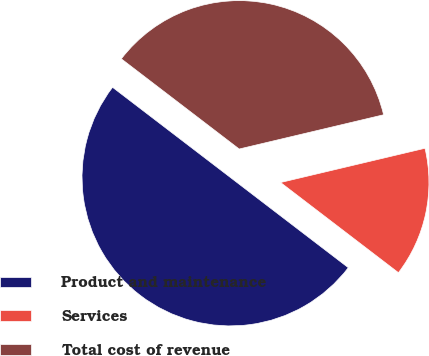<chart> <loc_0><loc_0><loc_500><loc_500><pie_chart><fcel>Product and maintenance<fcel>Services<fcel>Total cost of revenue<nl><fcel>50.0%<fcel>14.1%<fcel>35.9%<nl></chart> 